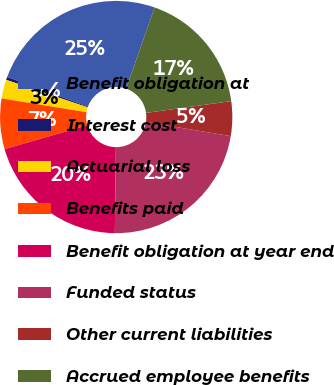Convert chart. <chart><loc_0><loc_0><loc_500><loc_500><pie_chart><fcel>Benefit obligation at<fcel>Interest cost<fcel>Actuarial loss<fcel>Benefits paid<fcel>Benefit obligation at year end<fcel>Funded status<fcel>Other current liabilities<fcel>Accrued employee benefits<nl><fcel>24.76%<fcel>0.42%<fcel>2.62%<fcel>7.02%<fcel>20.36%<fcel>22.56%<fcel>4.82%<fcel>17.45%<nl></chart> 